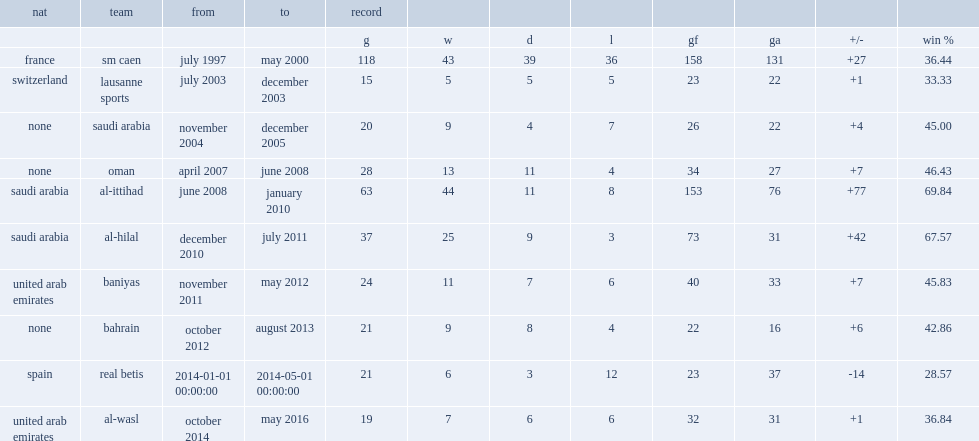Which team did gabriel calderon play for from january 2014 to may 2014? Real betis. 